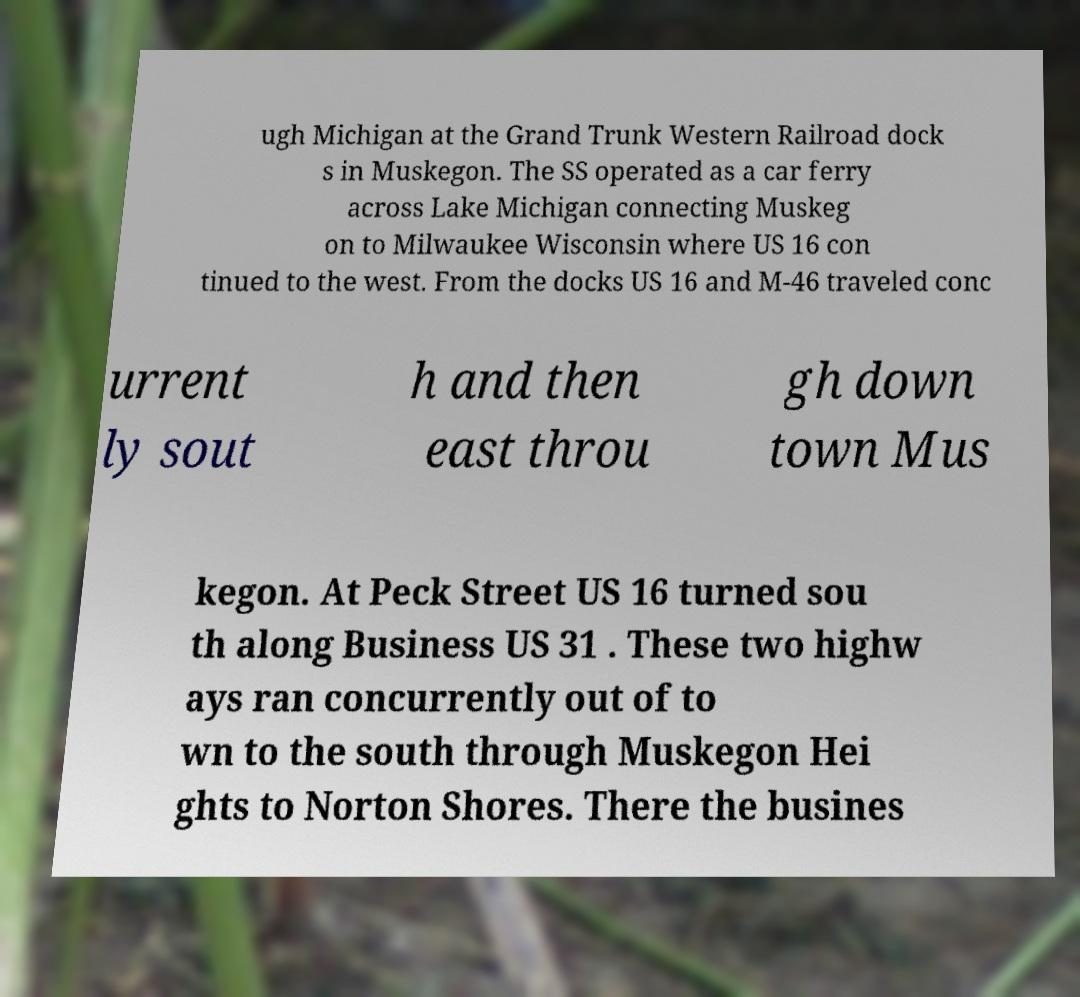What messages or text are displayed in this image? I need them in a readable, typed format. ugh Michigan at the Grand Trunk Western Railroad dock s in Muskegon. The SS operated as a car ferry across Lake Michigan connecting Muskeg on to Milwaukee Wisconsin where US 16 con tinued to the west. From the docks US 16 and M-46 traveled conc urrent ly sout h and then east throu gh down town Mus kegon. At Peck Street US 16 turned sou th along Business US 31 . These two highw ays ran concurrently out of to wn to the south through Muskegon Hei ghts to Norton Shores. There the busines 